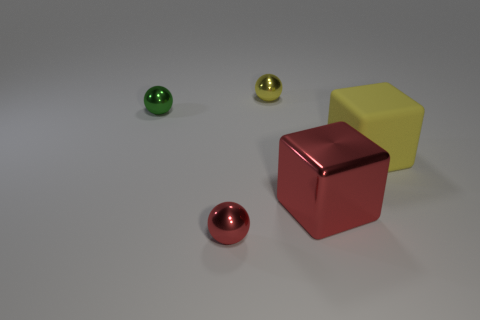Can you infer anything about the lighting in this scene based on the shadows of the objects? The shadows cast by the objects indicate a light source that is positioned to the upper left of the scene, as evidenced by the angle and direction of the shadows. The soft edges of the shadows suggest that the light source is not extremely close to the objects, producing a softer diffusion of light. Could you guess the time of day if this were an outdoor setting based on the lighting? If this scene were outdoors, the softness and angle of the shadows might suggest it's either early morning or late afternoon, when the sun is at a lower angle in the sky. However, this could also be an artificial light source within an indoor setting, making it difficult to precisely deduce the time of day. 